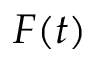Convert formula to latex. <formula><loc_0><loc_0><loc_500><loc_500>F ( t )</formula> 